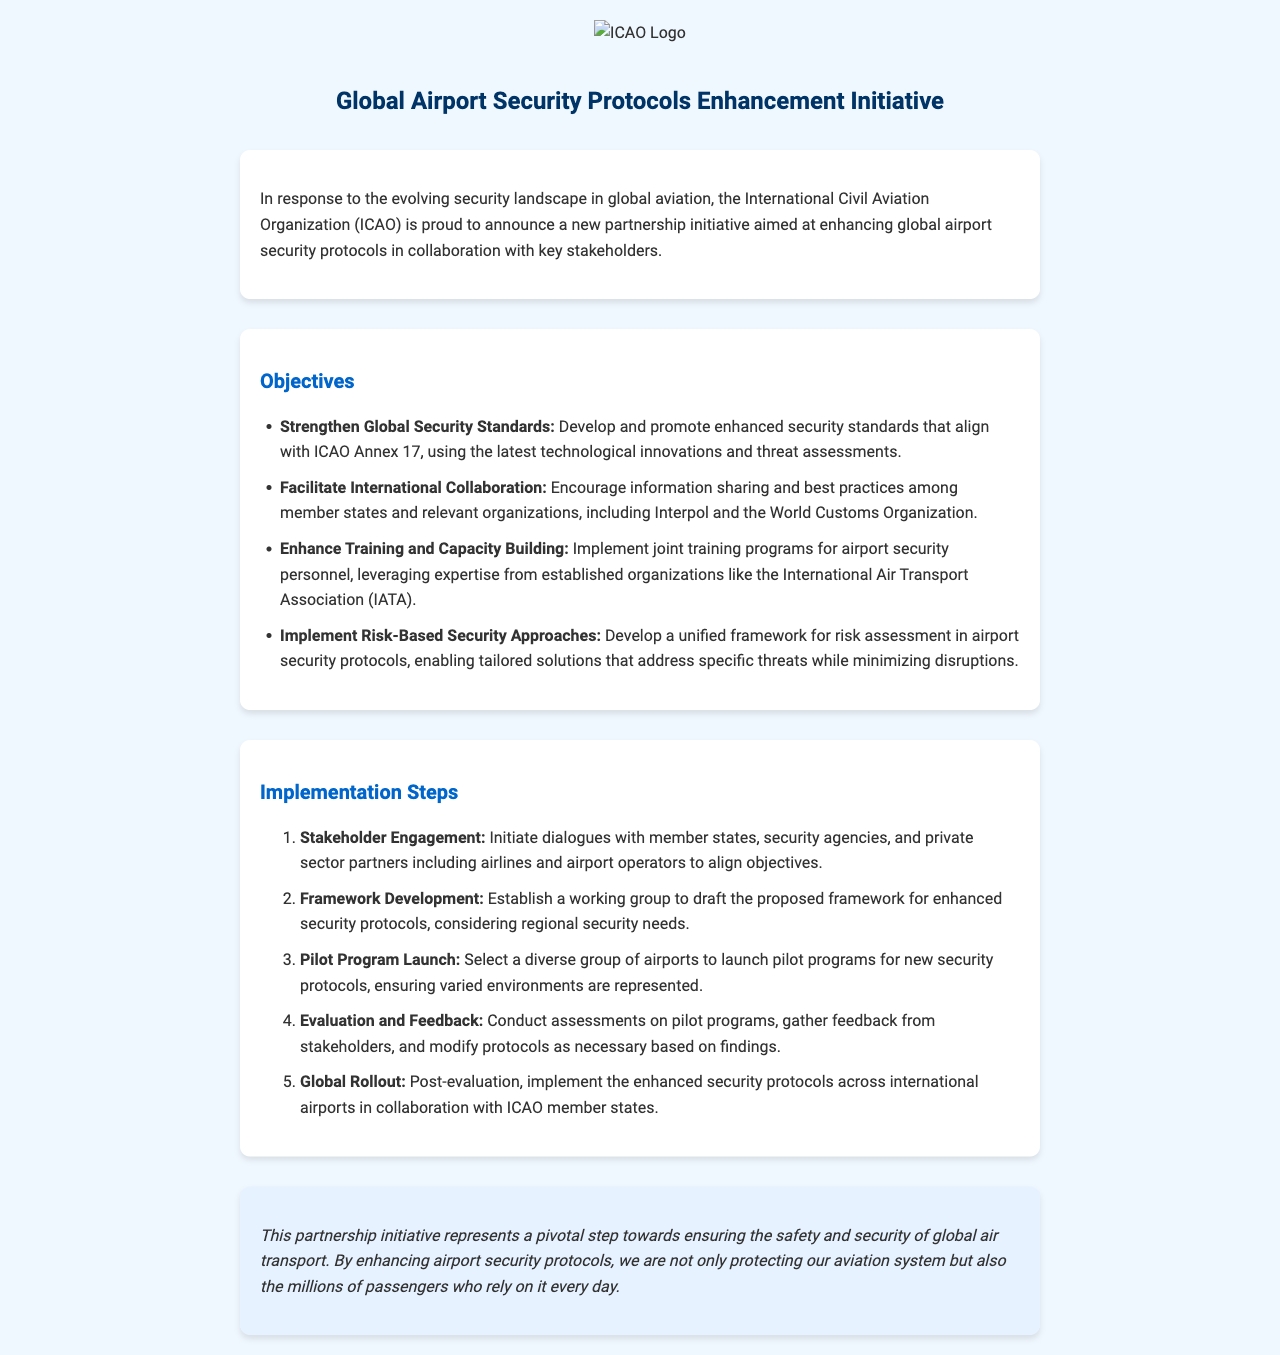What is the title of the initiative? The title of the initiative is specified in the header section of the document.
Answer: Global Airport Security Protocols Enhancement Initiative What organization is leading the initiative? The document identifies the leading organization responsible for the initiative.
Answer: International Civil Aviation Organization (ICAO) What is one of the objectives related to training? The objectives section outlines specific focuses, including training enhancements.
Answer: Enhance Training and Capacity Building How many implementation steps are outlined in the document? The implementation steps are numbered in an ordered list in the document.
Answer: Five What type of organizations are encouraged to share information? The objectives mention the involvement of multiple organizations in sharing best practices.
Answer: Member states and relevant organizations What is the primary aim of this partnership initiative? The conclusion of the document highlights the overarching goal of the initiative.
Answer: Ensuring the safety and security of global air transport Which agency will be involved in collaboration according to the objectives? The objectives explicitly mention specific organizations that will work together.
Answer: Interpol What is the last step in the implementation plan? The steps are listed sequentially, identifying the final action in the plan.
Answer: Global Rollout 